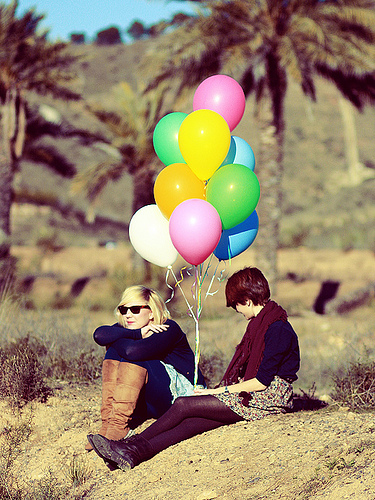<image>
Is the balloon next to the head? Yes. The balloon is positioned adjacent to the head, located nearby in the same general area. Where is the balloon in relation to the sunglasses? Is it in the sunglasses? No. The balloon is not contained within the sunglasses. These objects have a different spatial relationship. Is the balloon one behind the balloon two? Yes. From this viewpoint, the balloon one is positioned behind the balloon two, with the balloon two partially or fully occluding the balloon one. Where is the green balloon in relation to the orange balloon? Is it in front of the orange balloon? No. The green balloon is not in front of the orange balloon. The spatial positioning shows a different relationship between these objects. Where is the green balloon in relation to the orange balloon? Is it to the left of the orange balloon? No. The green balloon is not to the left of the orange balloon. From this viewpoint, they have a different horizontal relationship. 